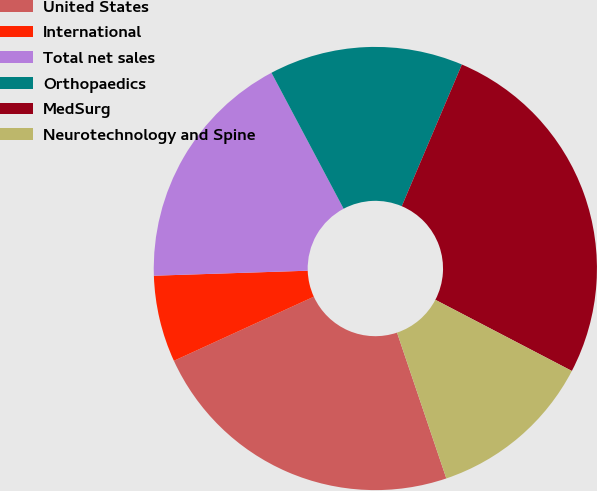Convert chart. <chart><loc_0><loc_0><loc_500><loc_500><pie_chart><fcel>United States<fcel>International<fcel>Total net sales<fcel>Orthopaedics<fcel>MedSurg<fcel>Neurotechnology and Spine<nl><fcel>23.35%<fcel>6.32%<fcel>17.75%<fcel>14.15%<fcel>26.26%<fcel>12.16%<nl></chart> 